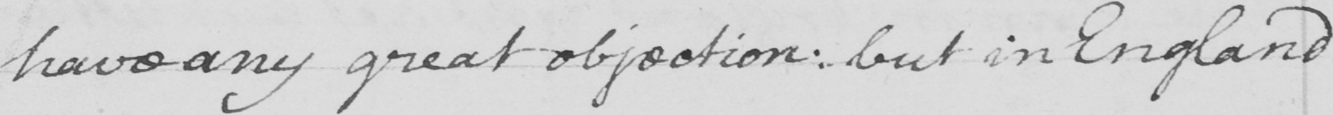Please transcribe the handwritten text in this image. have any great objection :  but in England 